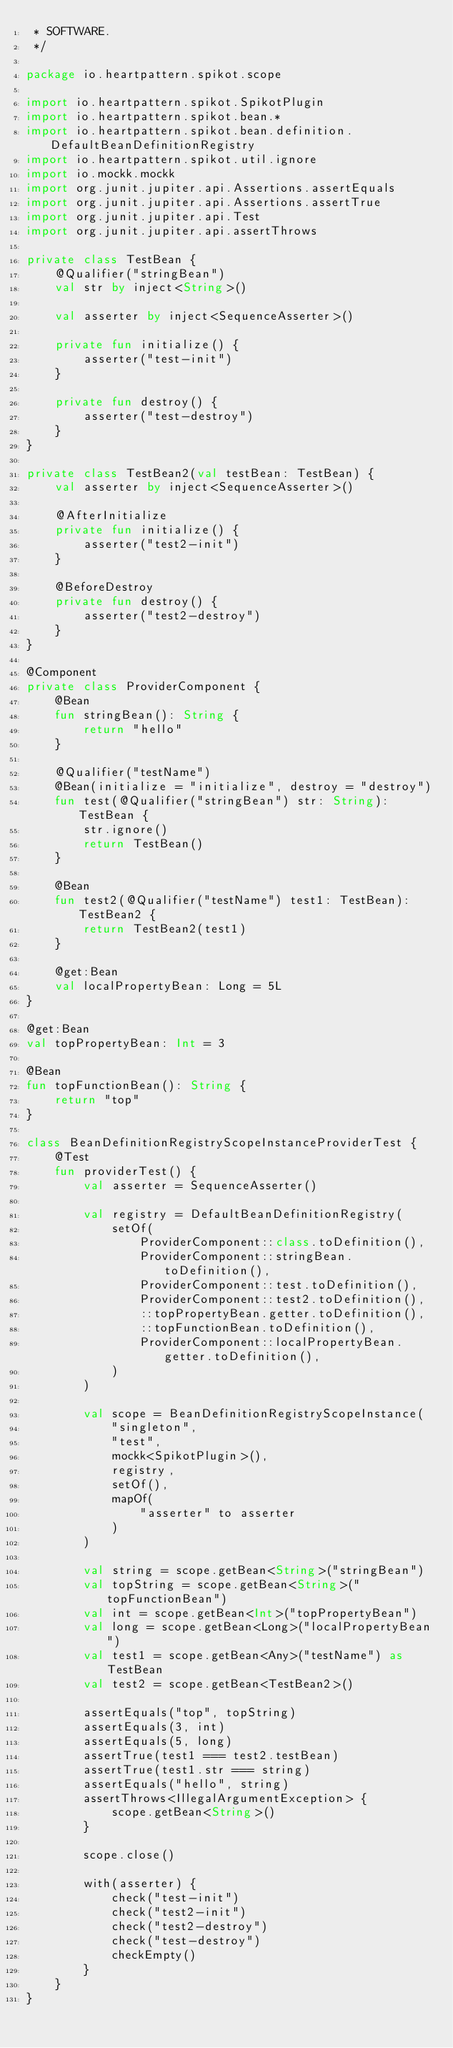Convert code to text. <code><loc_0><loc_0><loc_500><loc_500><_Kotlin_> * SOFTWARE.
 */

package io.heartpattern.spikot.scope

import io.heartpattern.spikot.SpikotPlugin
import io.heartpattern.spikot.bean.*
import io.heartpattern.spikot.bean.definition.DefaultBeanDefinitionRegistry
import io.heartpattern.spikot.util.ignore
import io.mockk.mockk
import org.junit.jupiter.api.Assertions.assertEquals
import org.junit.jupiter.api.Assertions.assertTrue
import org.junit.jupiter.api.Test
import org.junit.jupiter.api.assertThrows

private class TestBean {
    @Qualifier("stringBean")
    val str by inject<String>()

    val asserter by inject<SequenceAsserter>()

    private fun initialize() {
        asserter("test-init")
    }

    private fun destroy() {
        asserter("test-destroy")
    }
}

private class TestBean2(val testBean: TestBean) {
    val asserter by inject<SequenceAsserter>()

    @AfterInitialize
    private fun initialize() {
        asserter("test2-init")
    }

    @BeforeDestroy
    private fun destroy() {
        asserter("test2-destroy")
    }
}

@Component
private class ProviderComponent {
    @Bean
    fun stringBean(): String {
        return "hello"
    }

    @Qualifier("testName")
    @Bean(initialize = "initialize", destroy = "destroy")
    fun test(@Qualifier("stringBean") str: String): TestBean {
        str.ignore()
        return TestBean()
    }

    @Bean
    fun test2(@Qualifier("testName") test1: TestBean): TestBean2 {
        return TestBean2(test1)
    }

    @get:Bean
    val localPropertyBean: Long = 5L
}

@get:Bean
val topPropertyBean: Int = 3

@Bean
fun topFunctionBean(): String {
    return "top"
}

class BeanDefinitionRegistryScopeInstanceProviderTest {
    @Test
    fun providerTest() {
        val asserter = SequenceAsserter()

        val registry = DefaultBeanDefinitionRegistry(
            setOf(
                ProviderComponent::class.toDefinition(),
                ProviderComponent::stringBean.toDefinition(),
                ProviderComponent::test.toDefinition(),
                ProviderComponent::test2.toDefinition(),
                ::topPropertyBean.getter.toDefinition(),
                ::topFunctionBean.toDefinition(),
                ProviderComponent::localPropertyBean.getter.toDefinition(),
            )
        )

        val scope = BeanDefinitionRegistryScopeInstance(
            "singleton",
            "test",
            mockk<SpikotPlugin>(),
            registry,
            setOf(),
            mapOf(
                "asserter" to asserter
            )
        )

        val string = scope.getBean<String>("stringBean")
        val topString = scope.getBean<String>("topFunctionBean")
        val int = scope.getBean<Int>("topPropertyBean")
        val long = scope.getBean<Long>("localPropertyBean")
        val test1 = scope.getBean<Any>("testName") as TestBean
        val test2 = scope.getBean<TestBean2>()

        assertEquals("top", topString)
        assertEquals(3, int)
        assertEquals(5, long)
        assertTrue(test1 === test2.testBean)
        assertTrue(test1.str === string)
        assertEquals("hello", string)
        assertThrows<IllegalArgumentException> {
            scope.getBean<String>()
        }

        scope.close()

        with(asserter) {
            check("test-init")
            check("test2-init")
            check("test2-destroy")
            check("test-destroy")
            checkEmpty()
        }
    }
}</code> 